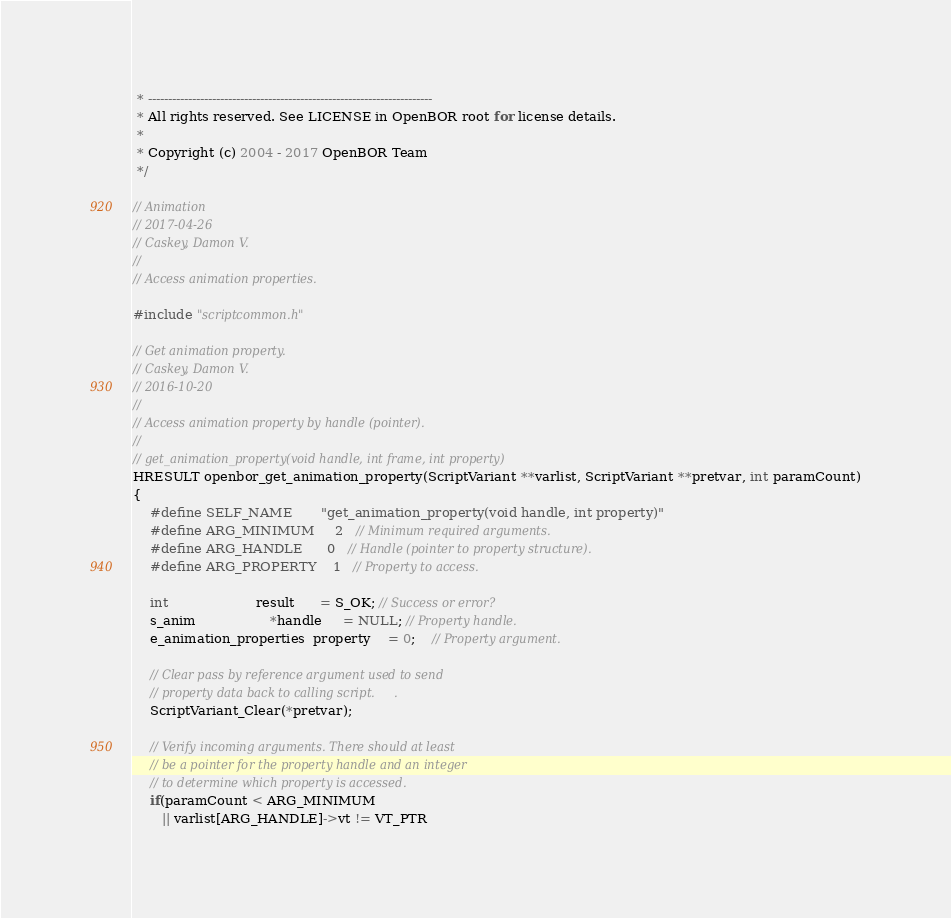Convert code to text. <code><loc_0><loc_0><loc_500><loc_500><_C_> * -----------------------------------------------------------------------
 * All rights reserved. See LICENSE in OpenBOR root for license details.
 *
 * Copyright (c) 2004 - 2017 OpenBOR Team
 */

// Animation
// 2017-04-26
// Caskey, Damon V.
//
// Access animation properties.

#include "scriptcommon.h"

// Get animation property.
// Caskey, Damon V.
// 2016-10-20
//
// Access animation property by handle (pointer).
//
// get_animation_property(void handle, int frame, int property)
HRESULT openbor_get_animation_property(ScriptVariant **varlist, ScriptVariant **pretvar, int paramCount)
{
    #define SELF_NAME       "get_animation_property(void handle, int property)"
    #define ARG_MINIMUM     2   // Minimum required arguments.
    #define ARG_HANDLE      0   // Handle (pointer to property structure).
    #define ARG_PROPERTY    1   // Property to access.

    int                     result      = S_OK; // Success or error?
    s_anim                  *handle     = NULL; // Property handle.
    e_animation_properties  property    = 0;    // Property argument.

    // Clear pass by reference argument used to send
    // property data back to calling script.     .
    ScriptVariant_Clear(*pretvar);

    // Verify incoming arguments. There should at least
    // be a pointer for the property handle and an integer
    // to determine which property is accessed.
    if(paramCount < ARG_MINIMUM
       || varlist[ARG_HANDLE]->vt != VT_PTR</code> 